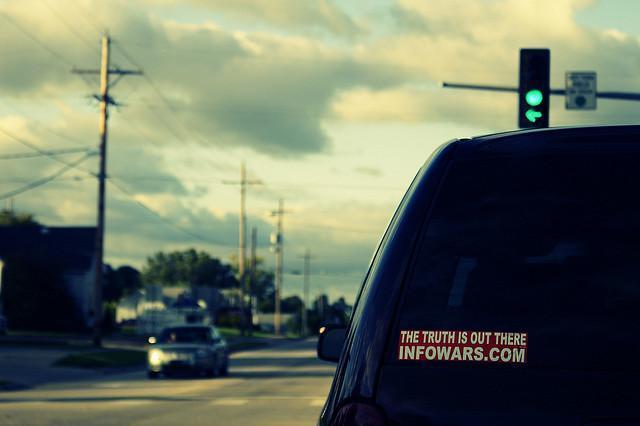How many cars are in the photo?
Give a very brief answer. 2. 